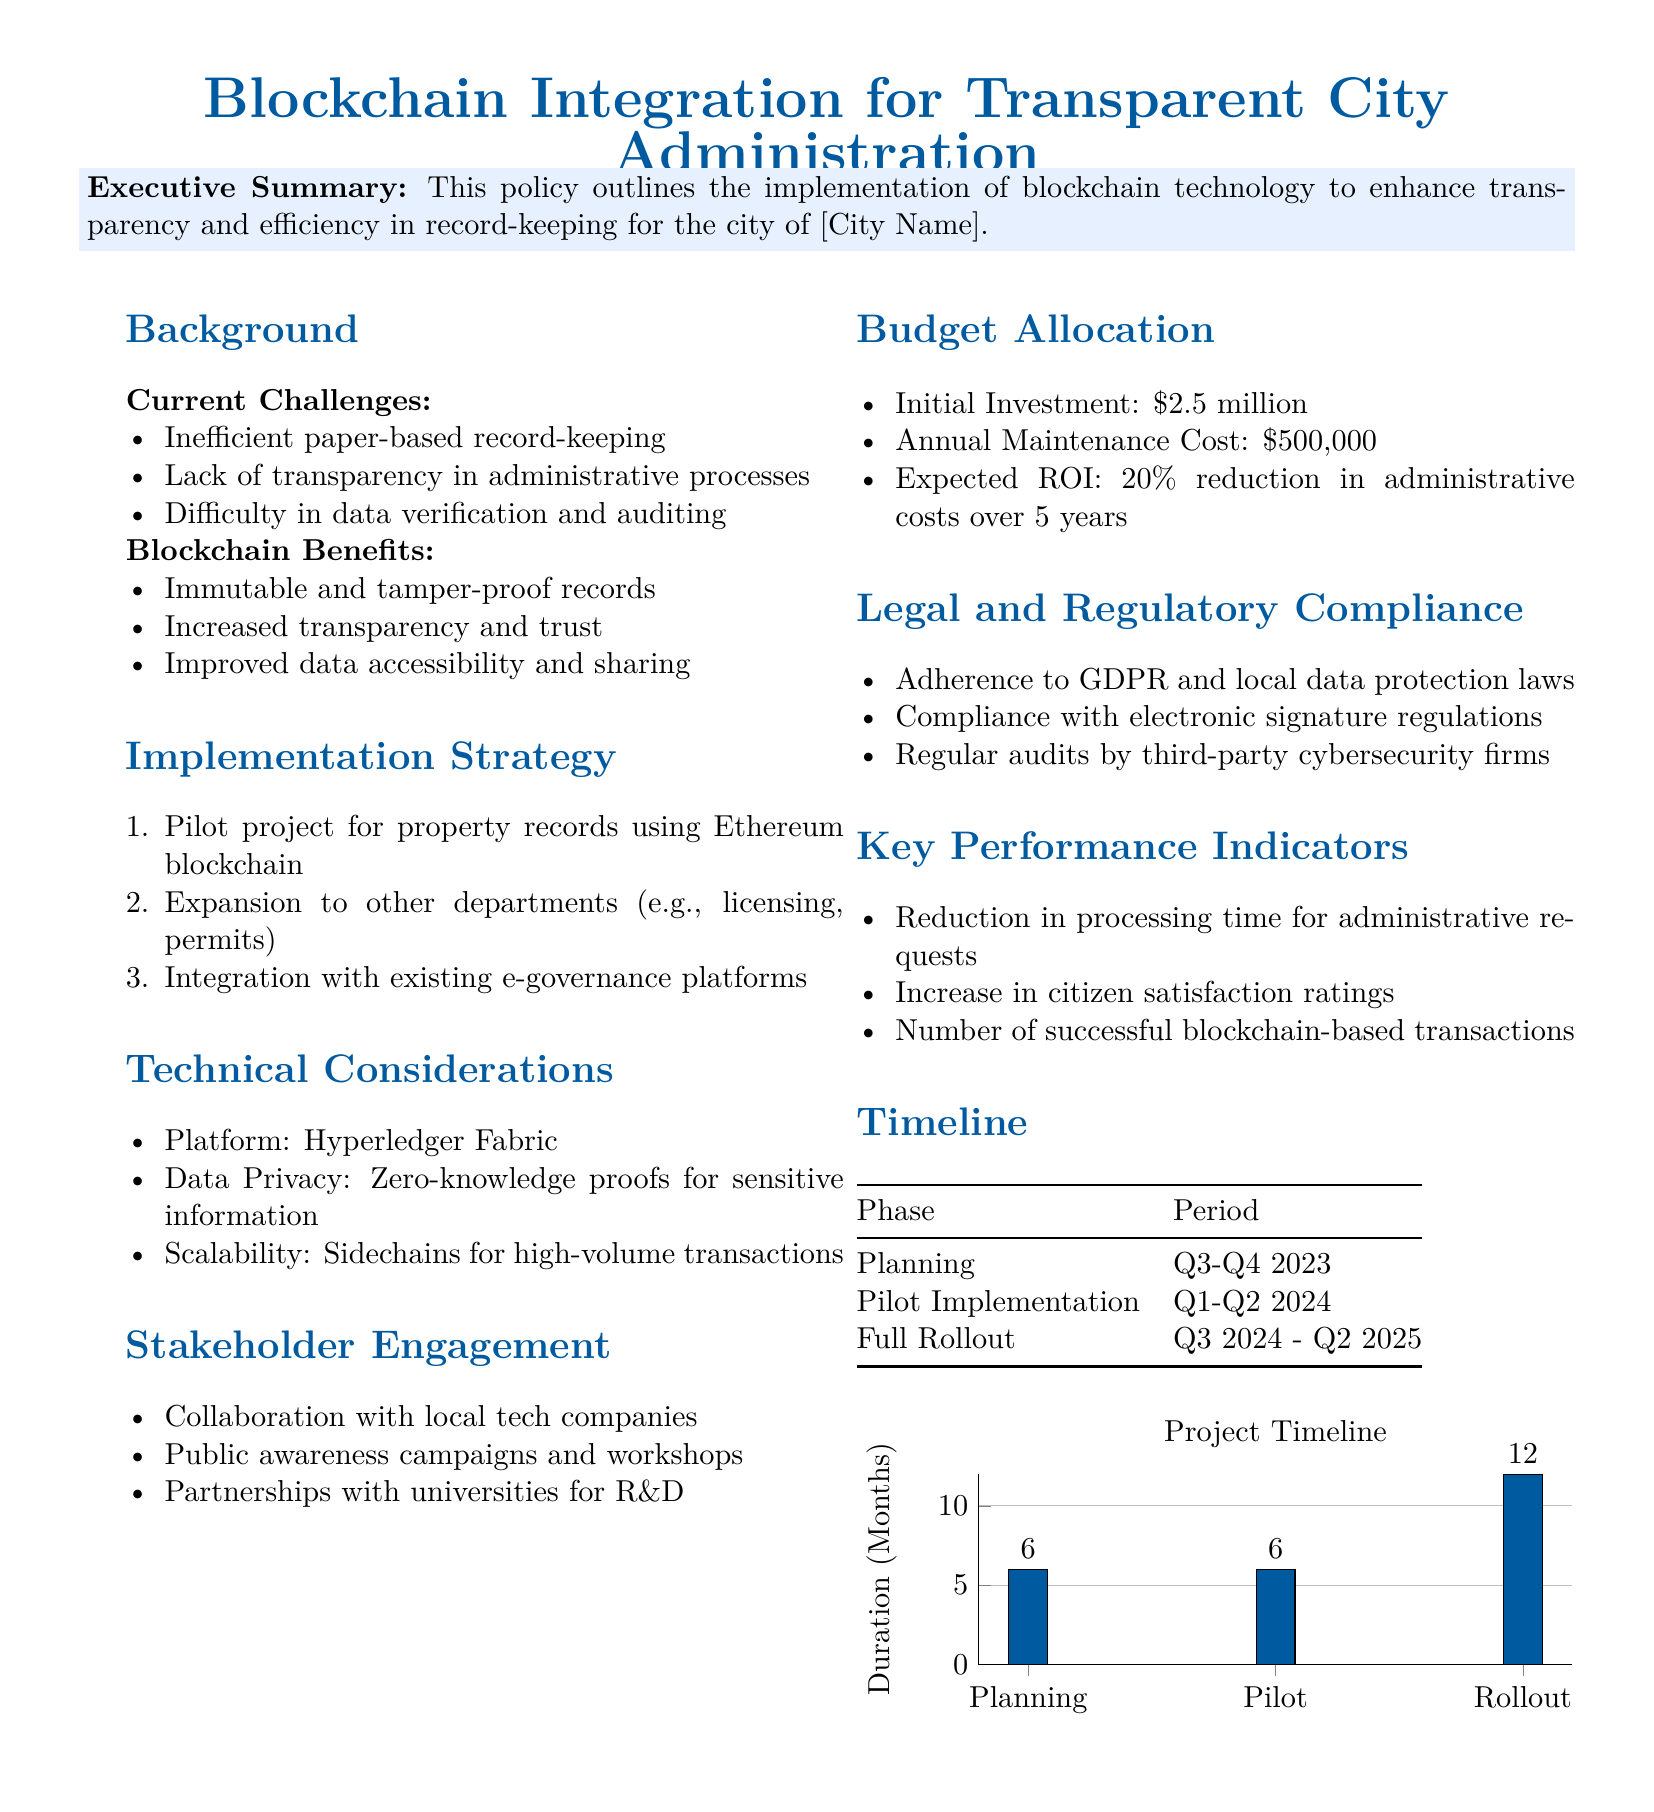What is the initial investment for the blockchain project? The initial investment is listed in the budget allocation section of the document.
Answer: $2.5 million What phase of the project occurs in Q1-Q2 2024? The pilot implementation phase is detailed in the timeline section of the document.
Answer: Pilot Implementation Which technology is proposed for the platform? The document specifies the platform technology in the technical considerations section.
Answer: Hyperledger Fabric What is the expected ROI over five years? The expected ROI is mentioned in the budget allocation section of the document.
Answer: 20% reduction What is one benefit of using blockchain technology? The benefits of blockchain technology are listed in the document under a specific section.
Answer: Increased transparency and trust How long is the full rollout planned to last? The timeline table indicates the duration of the full rollout phase.
Answer: 12 months What is mentioned as a component of stakeholder engagement? The strategies for stakeholder engagement are listed in a specific section of the document.
Answer: Public awareness campaigns and workshops Which data protection regulation must be complied with? Relevant legal compliance requirements are outlined in the legal and regulatory compliance section.
Answer: GDPR 